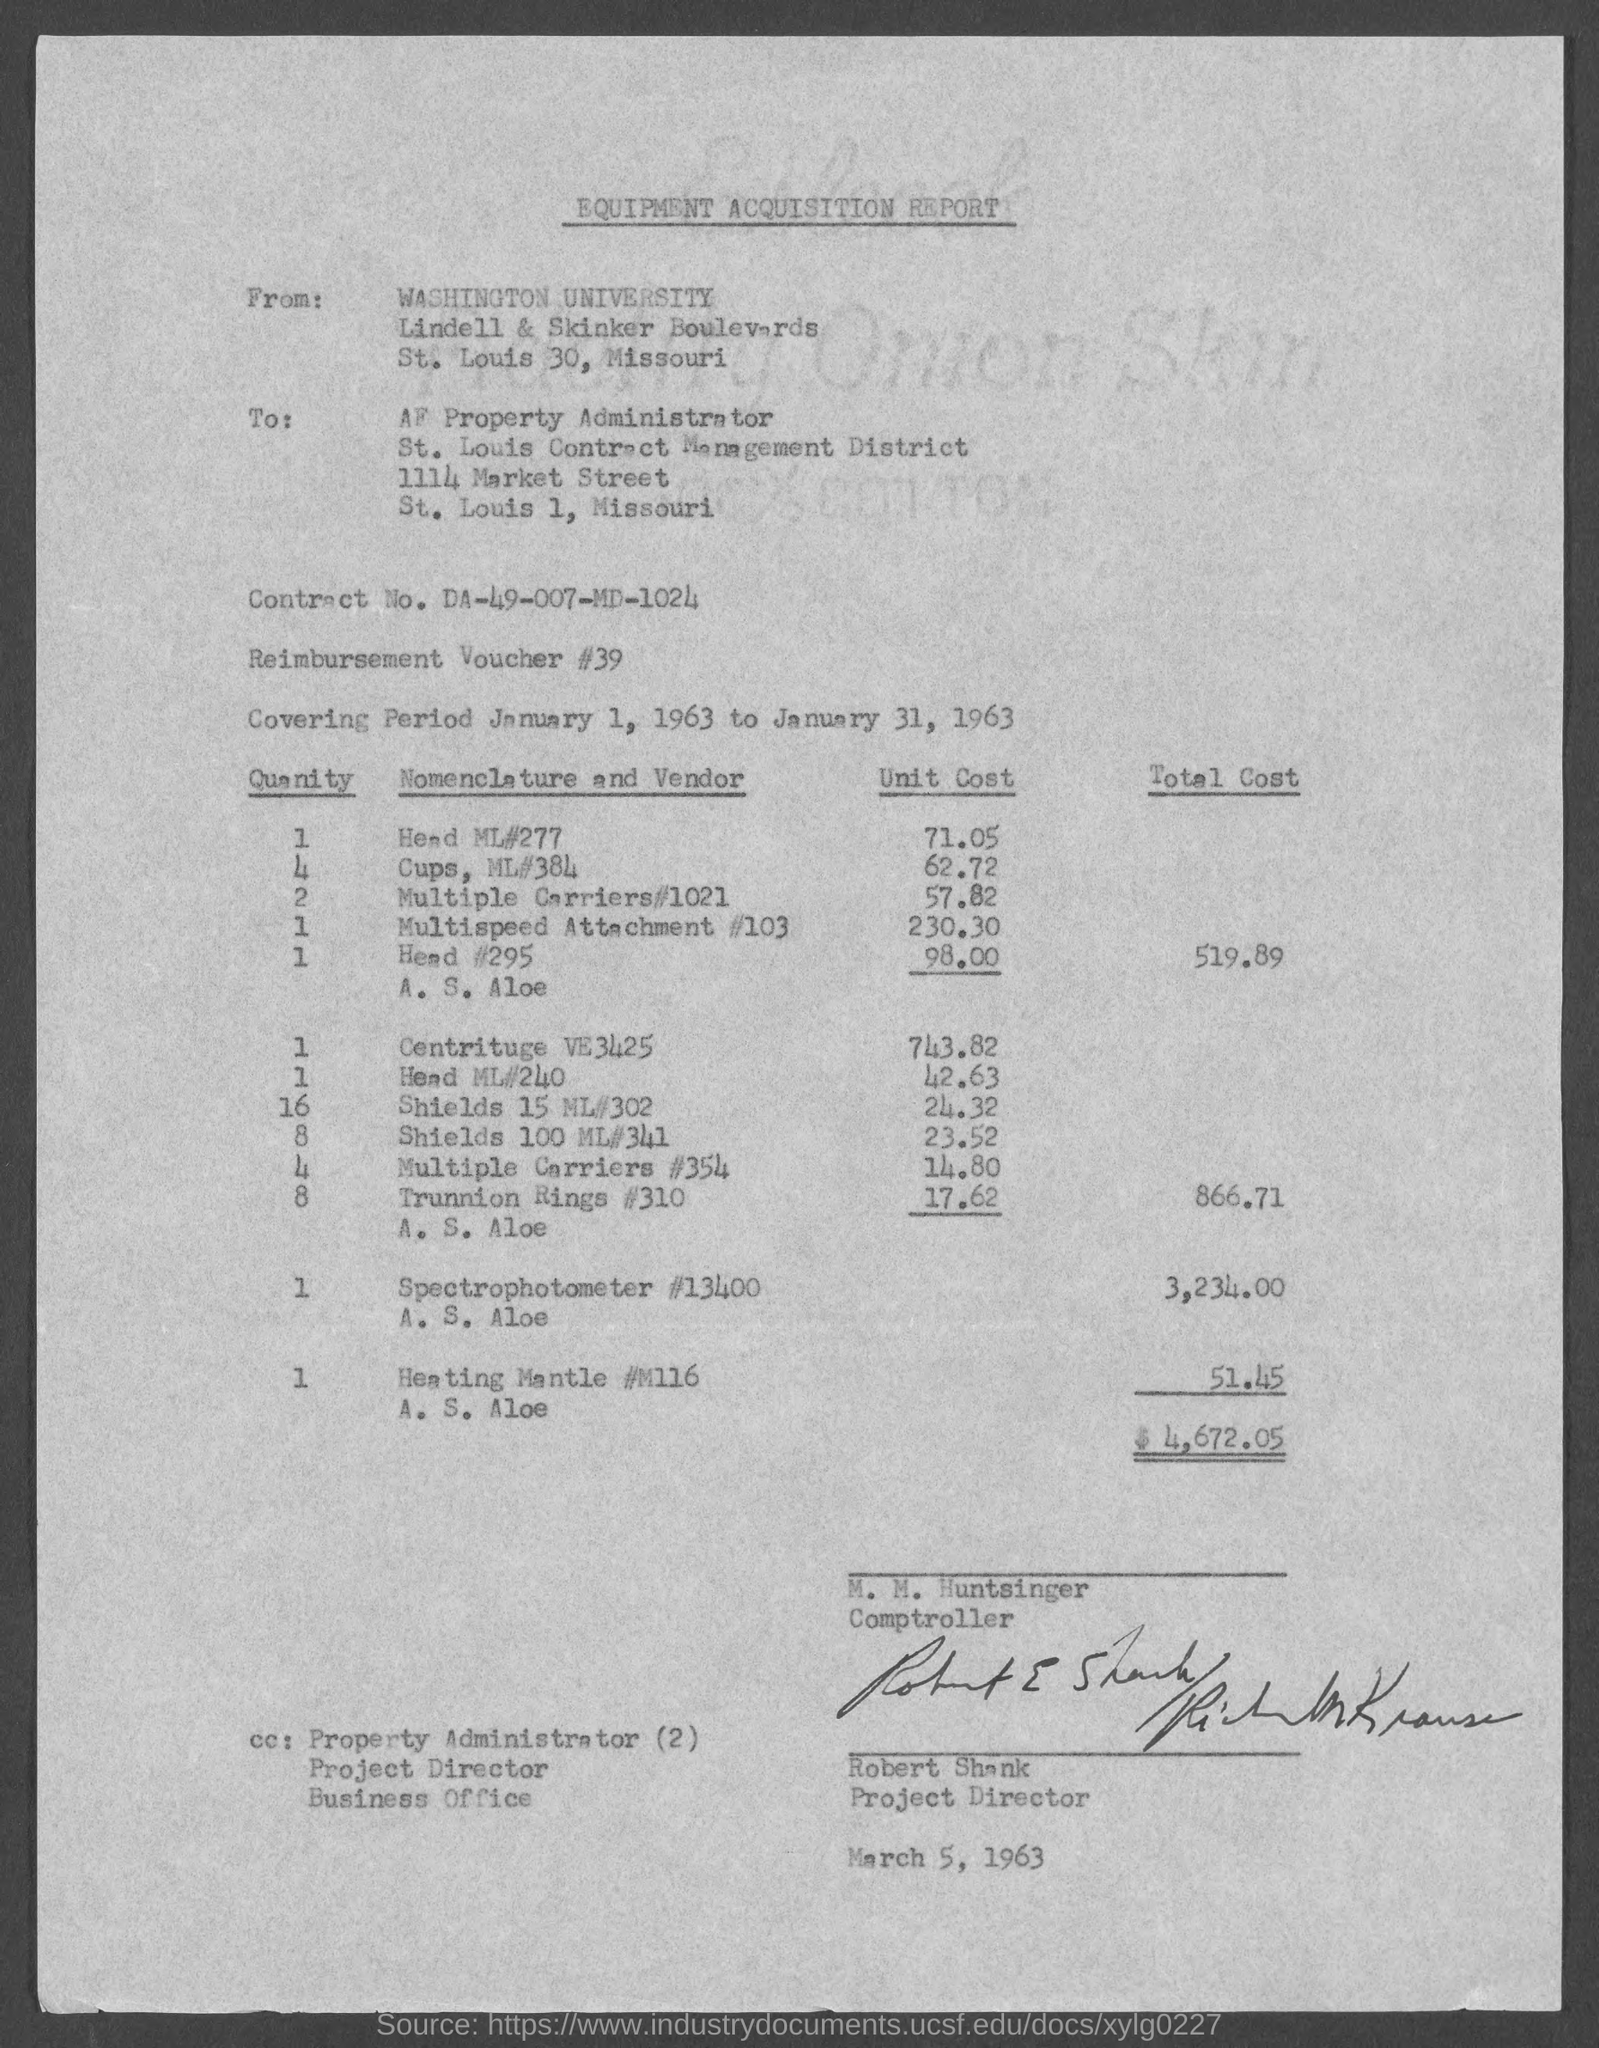What is the heading of the page?
Your answer should be compact. Equipment acquisition report. In which state is washington university located ?
Offer a terse response. Missouri. In which state is af property administrator located?
Ensure brevity in your answer.  Missouri. What is the contract no.?
Make the answer very short. DA-49-007-MD-1024. What is the reimbursement voucher # ?
Provide a short and direct response. 39. What is the position of m. m. huntsinger ?
Make the answer very short. Comptroller. What is the position of robert shank?
Offer a terse response. Project Director. 